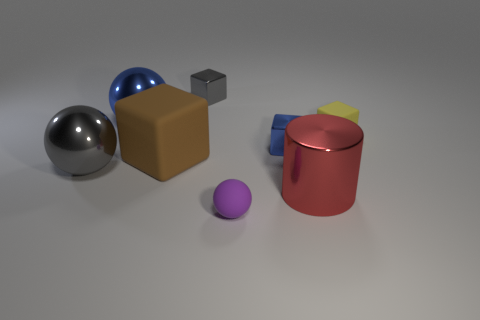Are there the same number of blue balls that are on the right side of the big red cylinder and small cyan matte things?
Give a very brief answer. Yes. What color is the matte cube that is to the left of the purple ball?
Make the answer very short. Brown. How many other objects are there of the same color as the tiny matte block?
Your answer should be very brief. 0. Is there anything else that is the same size as the brown matte block?
Your response must be concise. Yes. There is a gray metallic thing to the right of the blue sphere; is it the same size as the big brown object?
Ensure brevity in your answer.  No. What material is the big thing right of the gray metal cube?
Provide a short and direct response. Metal. Is there anything else that has the same shape as the brown rubber thing?
Offer a very short reply. Yes. How many metal things are big blue things or tiny purple objects?
Provide a succinct answer. 1. Are there fewer large spheres that are right of the big brown matte cube than small yellow metal cylinders?
Your response must be concise. No. The gray metal thing on the left side of the shiny cube behind the small metal cube that is in front of the big blue thing is what shape?
Make the answer very short. Sphere. 